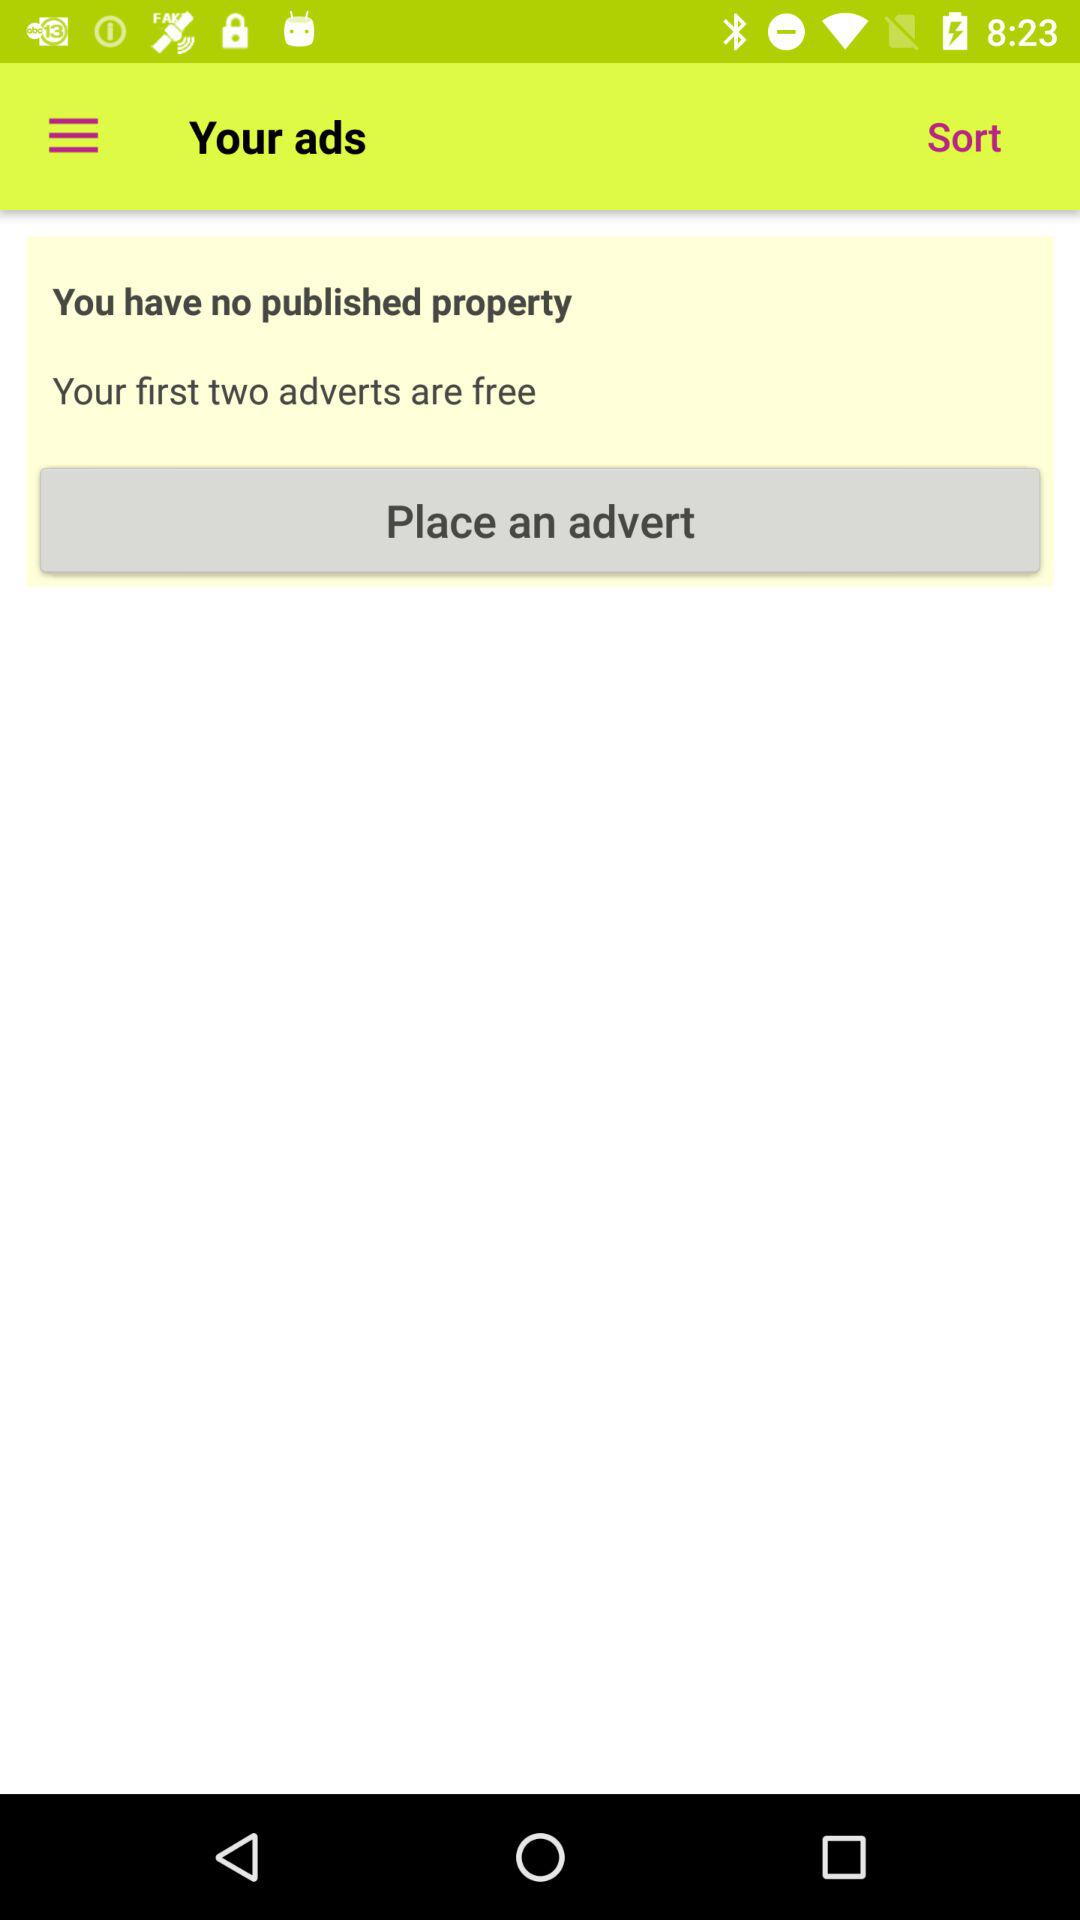How many adverts do I have published?
Answer the question using a single word or phrase. 0 